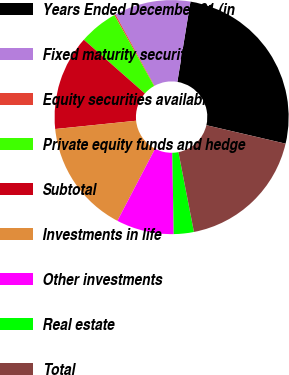Convert chart. <chart><loc_0><loc_0><loc_500><loc_500><pie_chart><fcel>Years Ended December 31 (in<fcel>Fixed maturity securities<fcel>Equity securities available<fcel>Private equity funds and hedge<fcel>Subtotal<fcel>Investments in life<fcel>Other investments<fcel>Real estate<fcel>Total<nl><fcel>26.07%<fcel>10.54%<fcel>0.18%<fcel>5.36%<fcel>13.12%<fcel>15.71%<fcel>7.95%<fcel>2.77%<fcel>18.3%<nl></chart> 